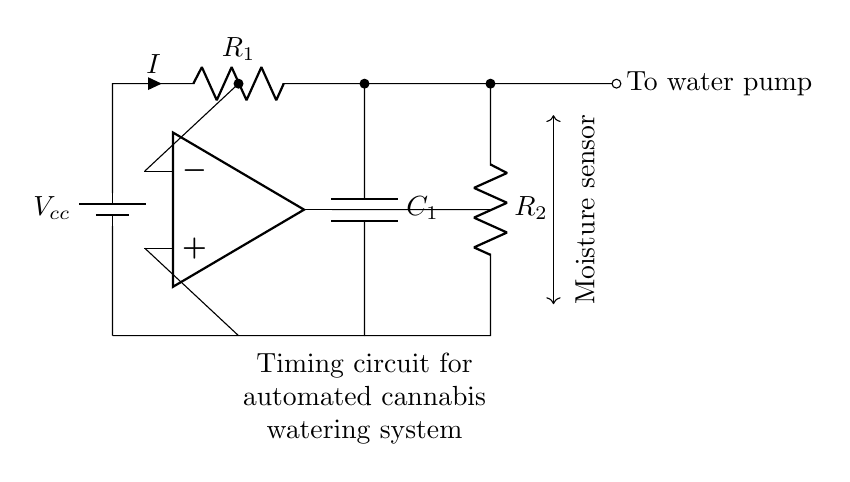What is the type of battery used in this circuit? The circuit uses a battery indicated as Vcc, which is typically a DC supply in electronic circuits.
Answer: Battery What component controls the current in the circuit? The resistor R1 dictates the amount of current flowing due to Ohm's law (V=IR).
Answer: R1 What is the role of the moisture sensor in this circuit? The moisture sensor detects soil moisture levels and sends signals to the op-amp, which can trigger the water pump based on those levels.
Answer: Control water pump What is the purpose of the capacitor C1? The capacitor is used for timing processes in the circuit by storing and releasing charge, affecting the timing of the watering action.
Answer: Timing How many resistors are present in this circuit? There are two resistors shown in the circuit diagram, R1 and R2, both crucial for controlling current flow.
Answer: Two What does the output of the op-amp connect to? The output of the op-amp connects to R2, leading to the water pump, thereby controlling the watering action.
Answer: R2 What is the schematic representation of the moisture sensor? The moisture sensor is represented by a notation that shows its role between the op-amp and the watering actuator.
Answer: Sensor node 